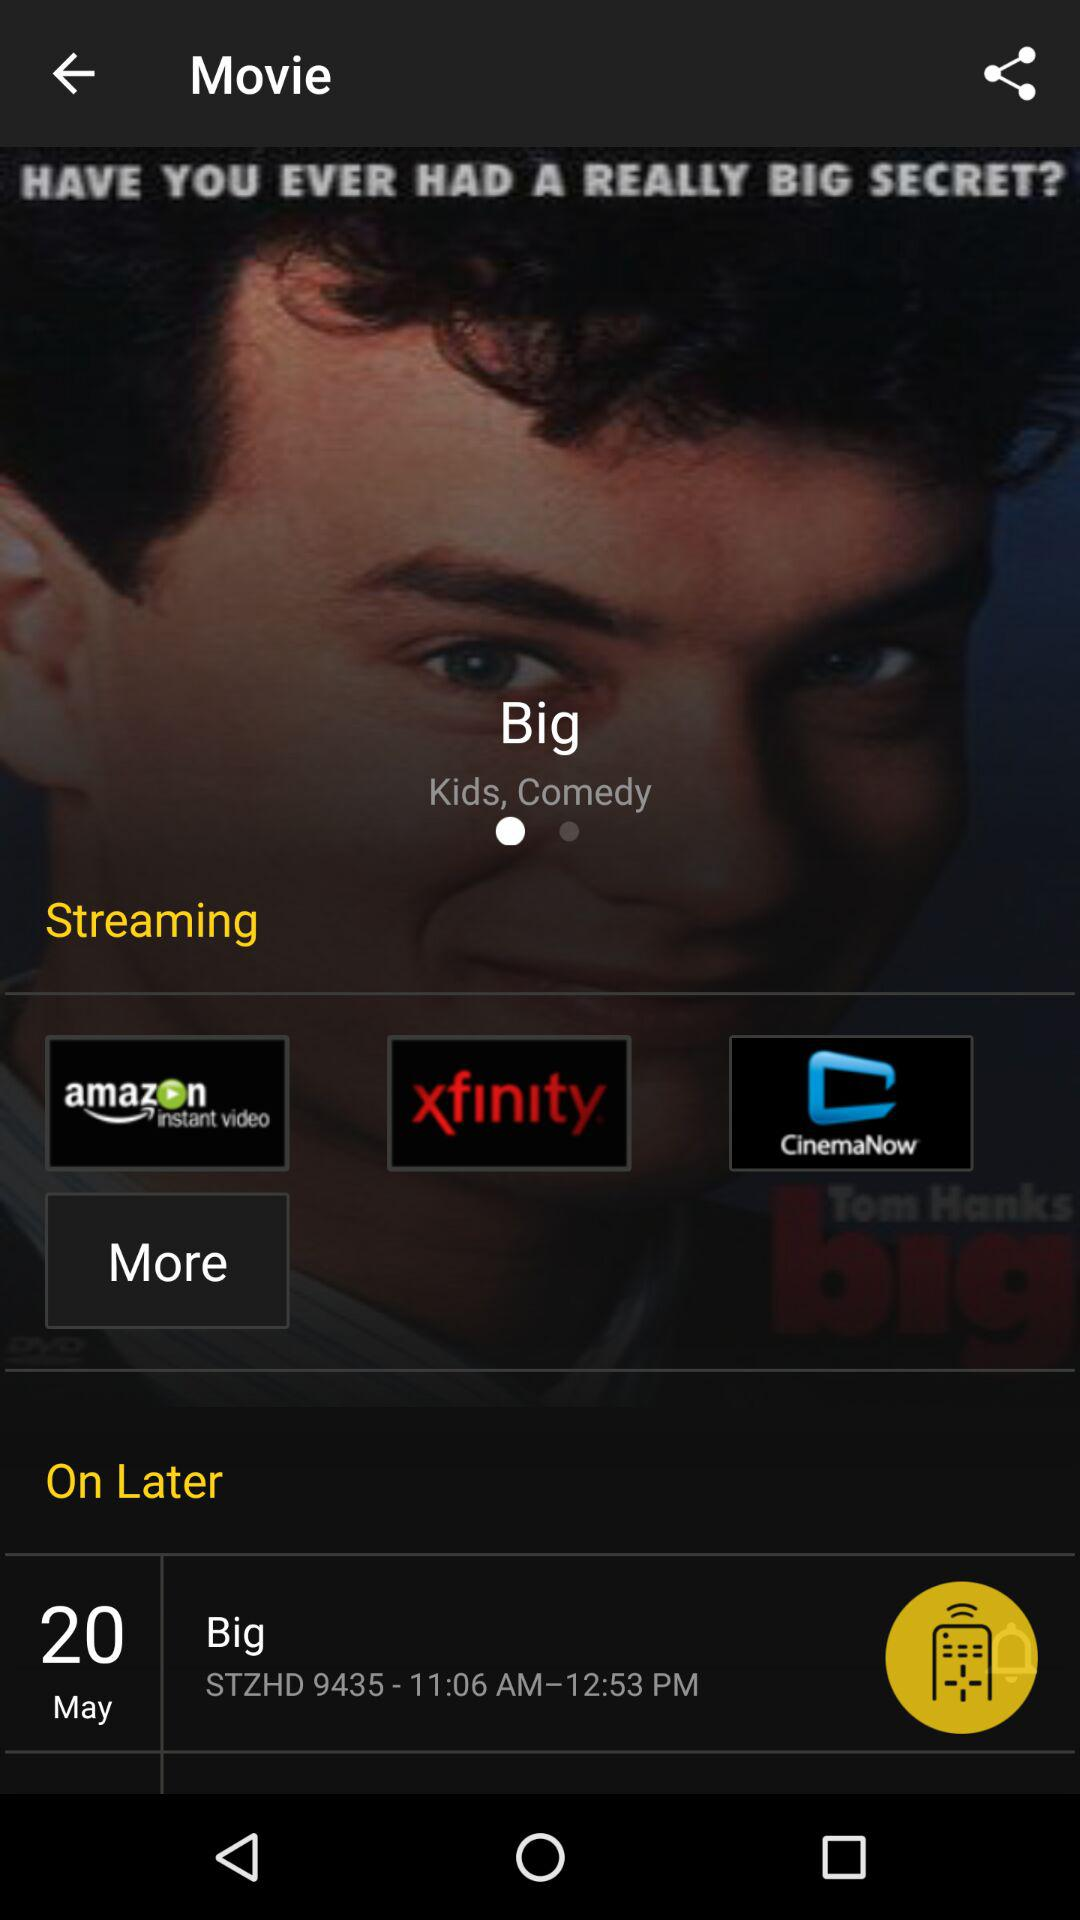What year was "Big" released?
When the provided information is insufficient, respond with <no answer>. <no answer> 